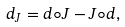Convert formula to latex. <formula><loc_0><loc_0><loc_500><loc_500>d _ { J } = d \circ J - J \circ d ,</formula> 